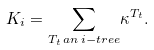Convert formula to latex. <formula><loc_0><loc_0><loc_500><loc_500>K _ { i } = \underset { T _ { t } \, a n \, i - t r e e } { \sum } \kappa ^ { T _ { t } } .</formula> 